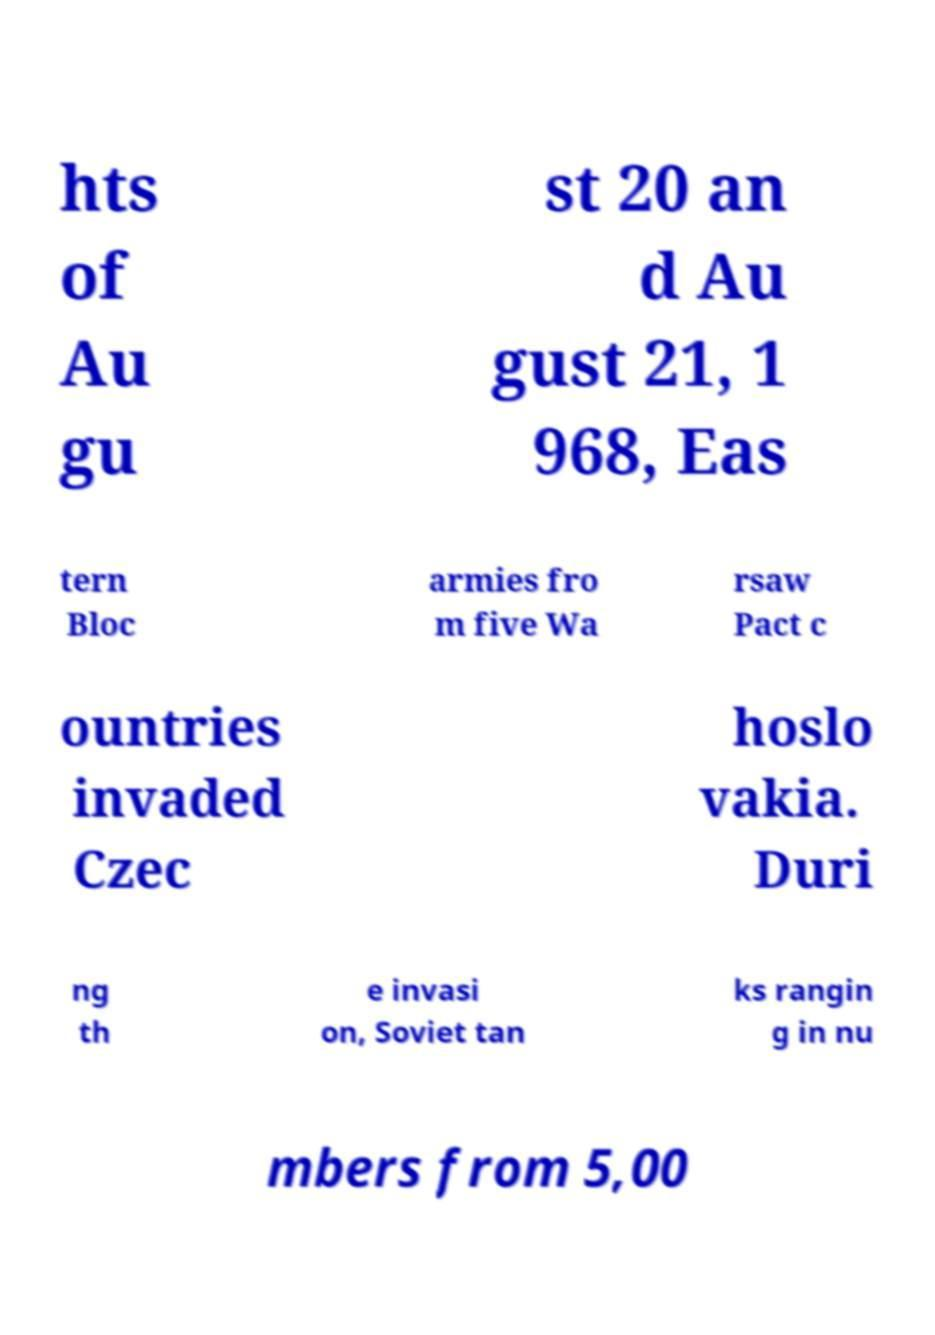Can you accurately transcribe the text from the provided image for me? hts of Au gu st 20 an d Au gust 21, 1 968, Eas tern Bloc armies fro m five Wa rsaw Pact c ountries invaded Czec hoslo vakia. Duri ng th e invasi on, Soviet tan ks rangin g in nu mbers from 5,00 